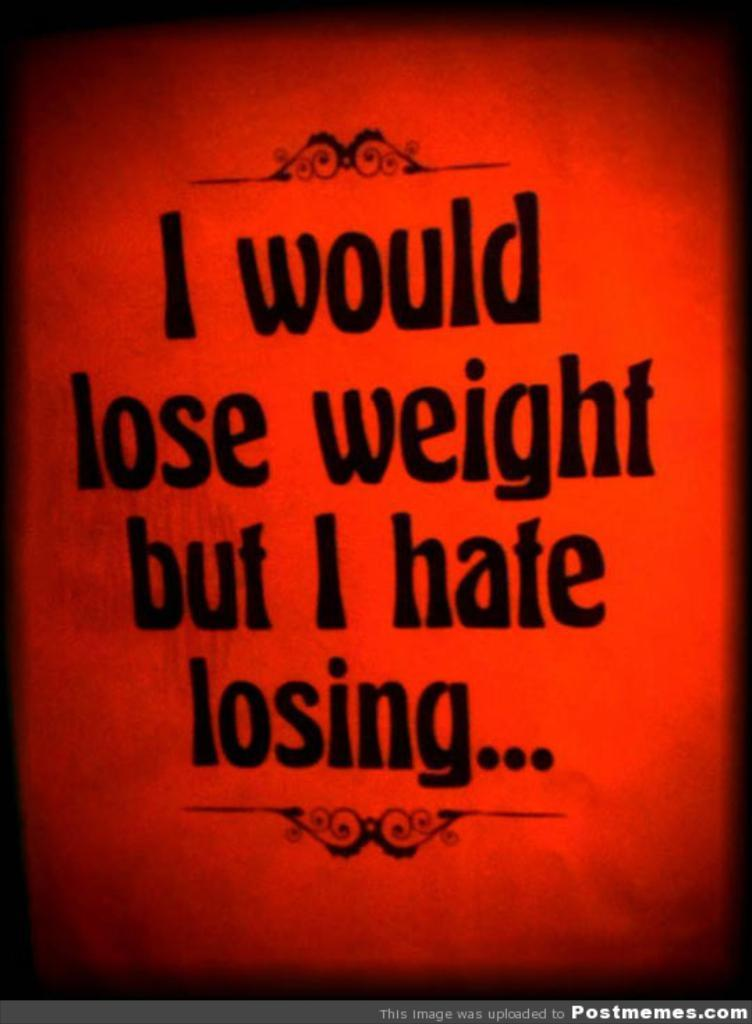<image>
Write a terse but informative summary of the picture. Red background with words that say "I would lose weight but i hate losing" in black letters. 